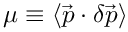Convert formula to latex. <formula><loc_0><loc_0><loc_500><loc_500>\mu \equiv \langle \vec { p } \cdot \delta \vec { p } \rangle</formula> 